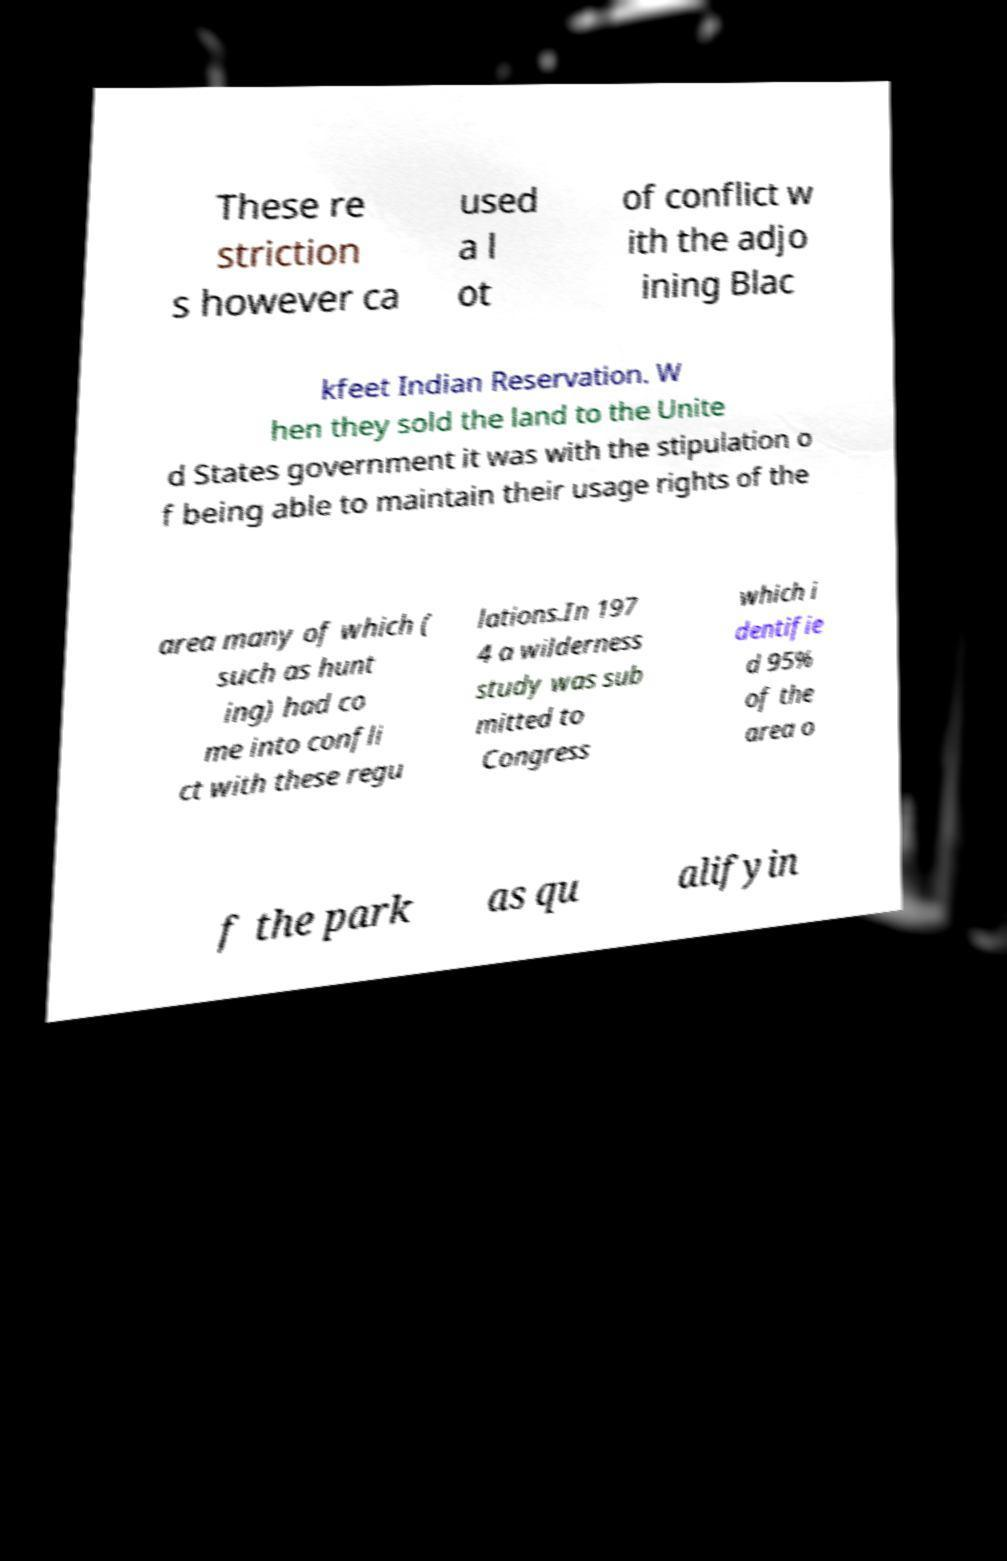For documentation purposes, I need the text within this image transcribed. Could you provide that? These re striction s however ca used a l ot of conflict w ith the adjo ining Blac kfeet Indian Reservation. W hen they sold the land to the Unite d States government it was with the stipulation o f being able to maintain their usage rights of the area many of which ( such as hunt ing) had co me into confli ct with these regu lations.In 197 4 a wilderness study was sub mitted to Congress which i dentifie d 95% of the area o f the park as qu alifyin 